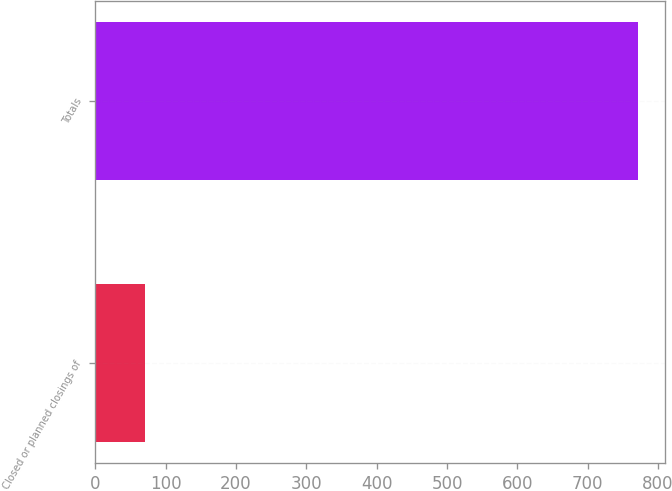Convert chart. <chart><loc_0><loc_0><loc_500><loc_500><bar_chart><fcel>Closed or planned closings of<fcel>Totals<nl><fcel>71<fcel>771<nl></chart> 